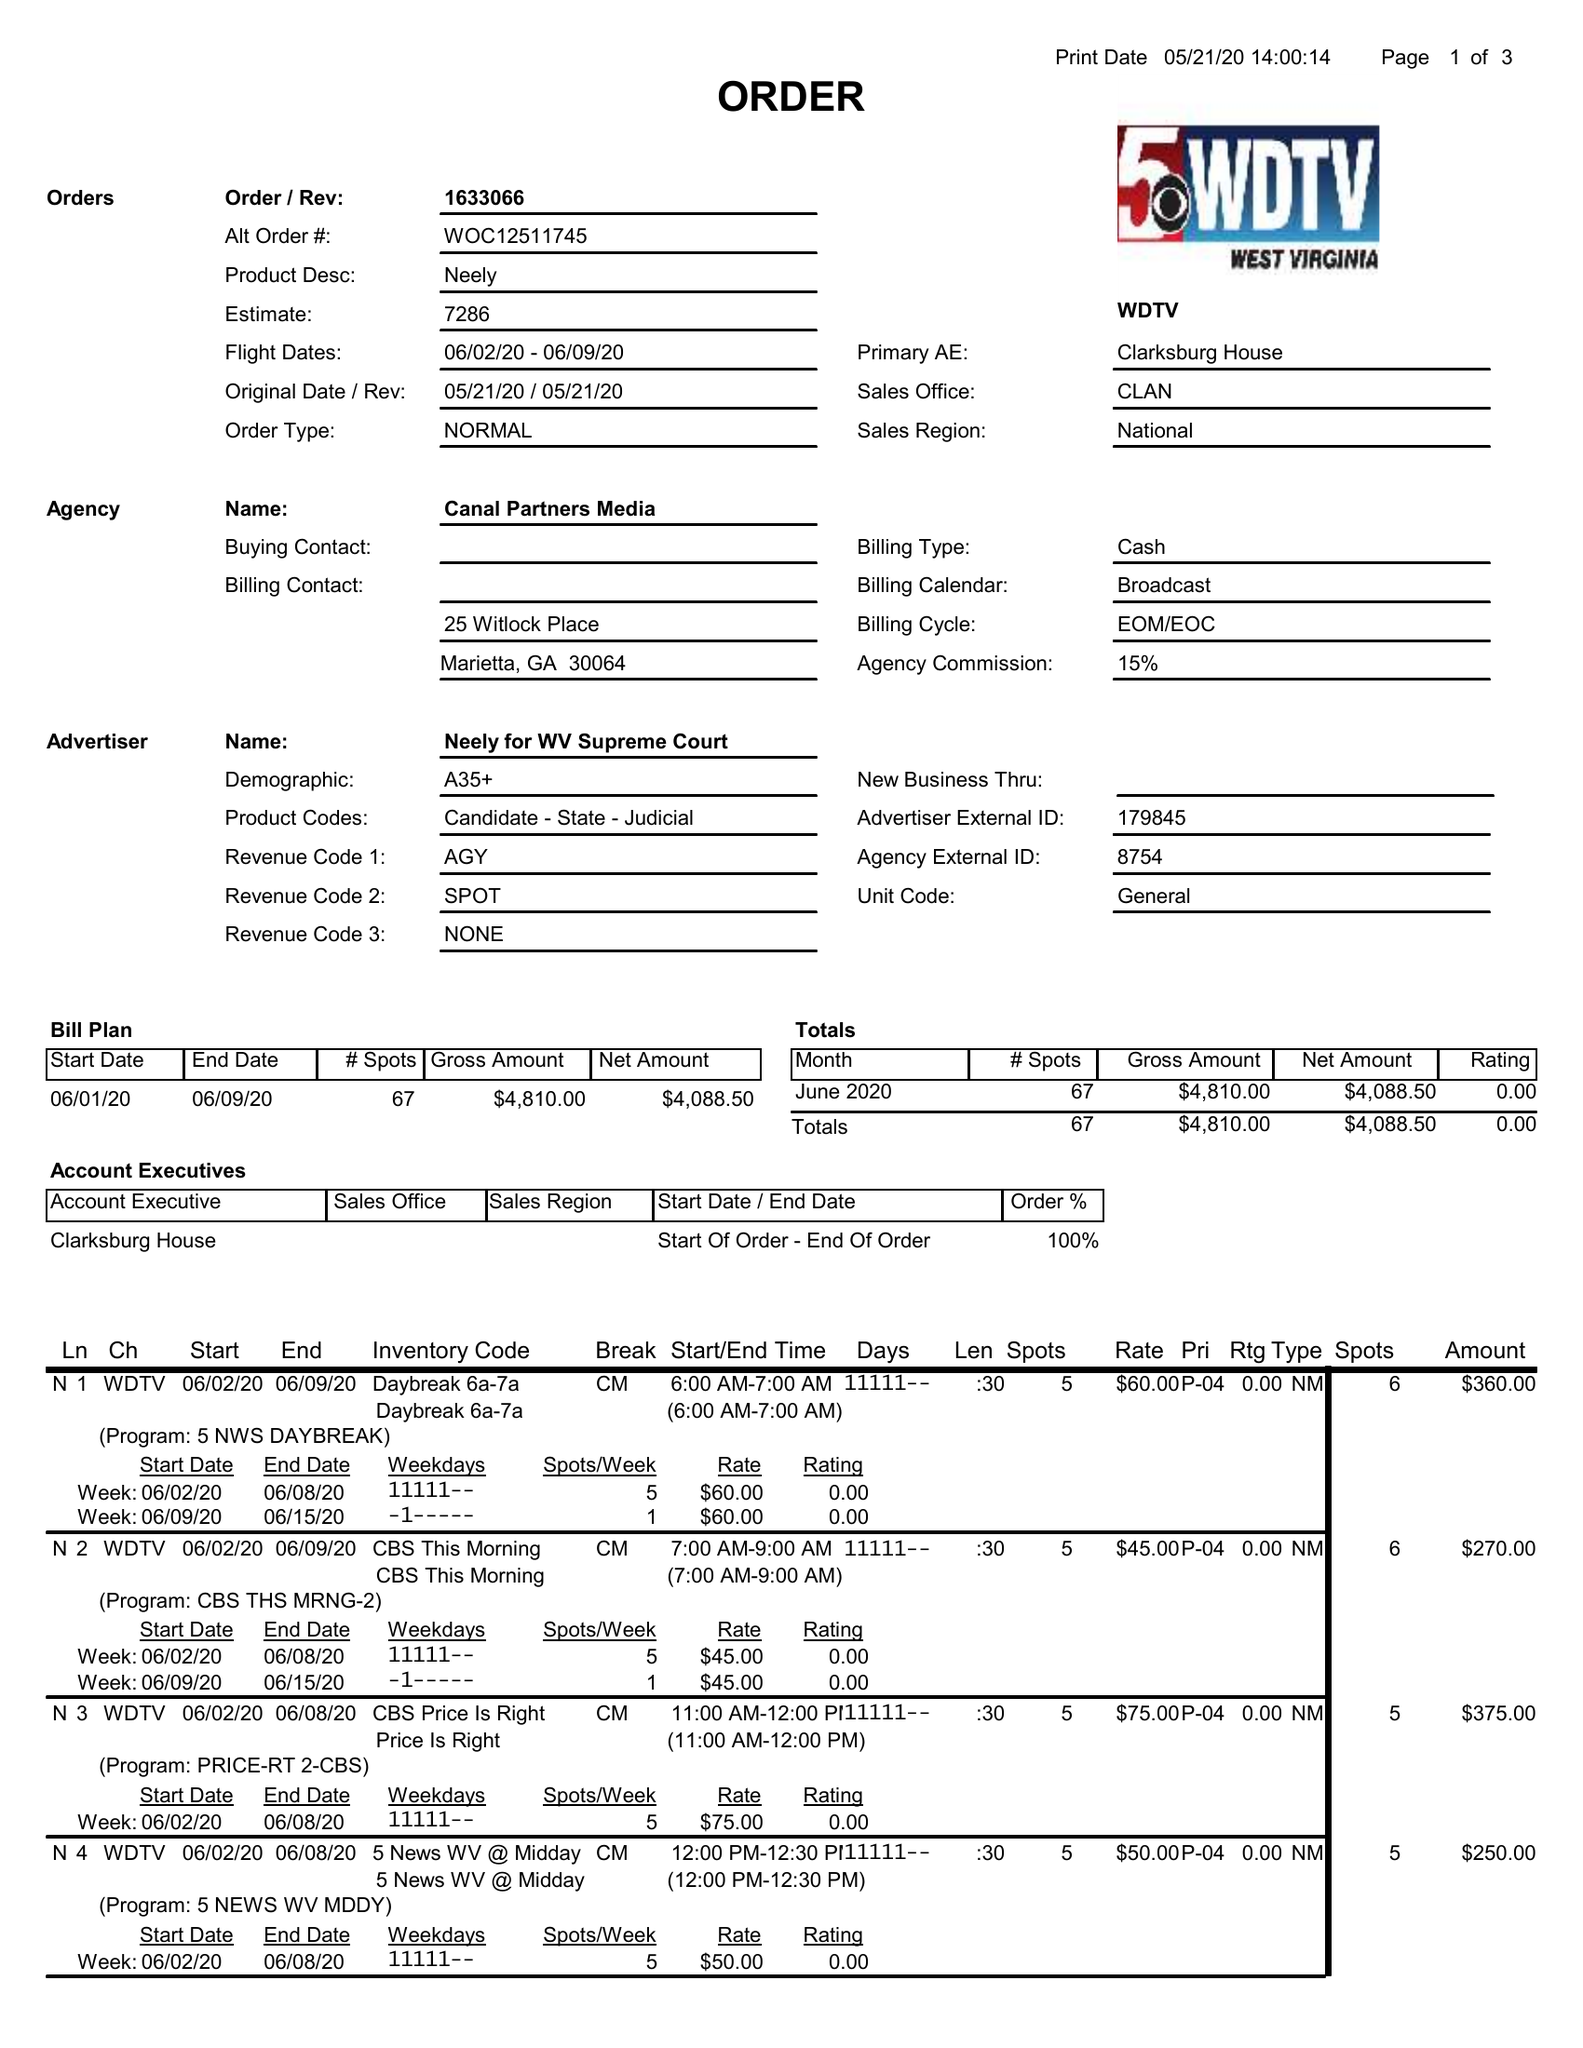What is the value for the advertiser?
Answer the question using a single word or phrase. NEELY FOR WV SUPREME COURT 